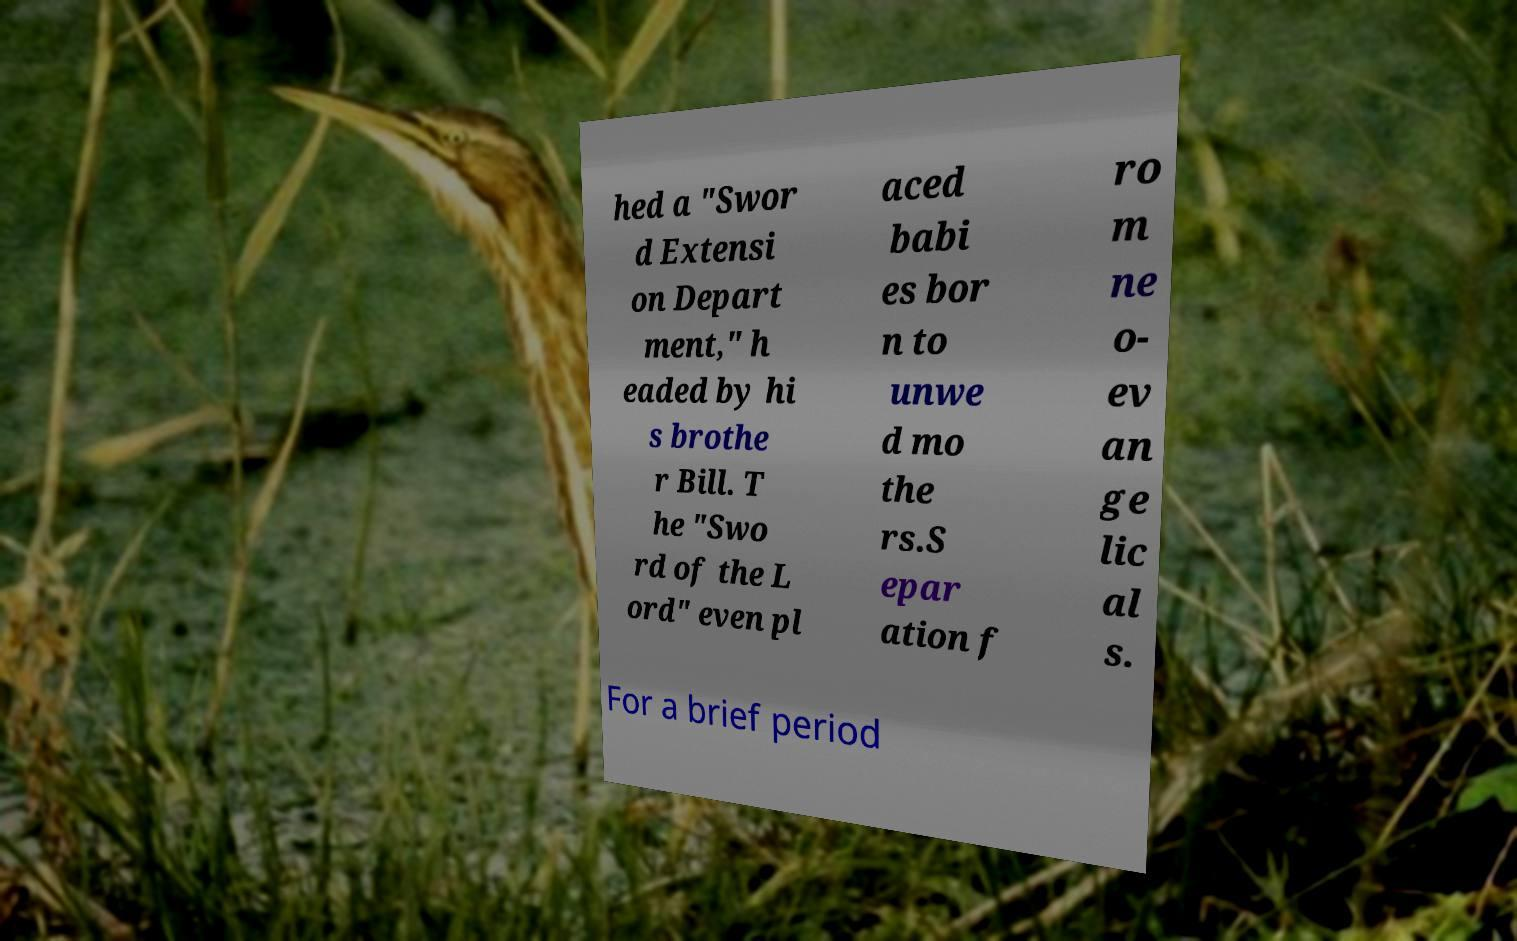I need the written content from this picture converted into text. Can you do that? hed a "Swor d Extensi on Depart ment," h eaded by hi s brothe r Bill. T he "Swo rd of the L ord" even pl aced babi es bor n to unwe d mo the rs.S epar ation f ro m ne o- ev an ge lic al s. For a brief period 